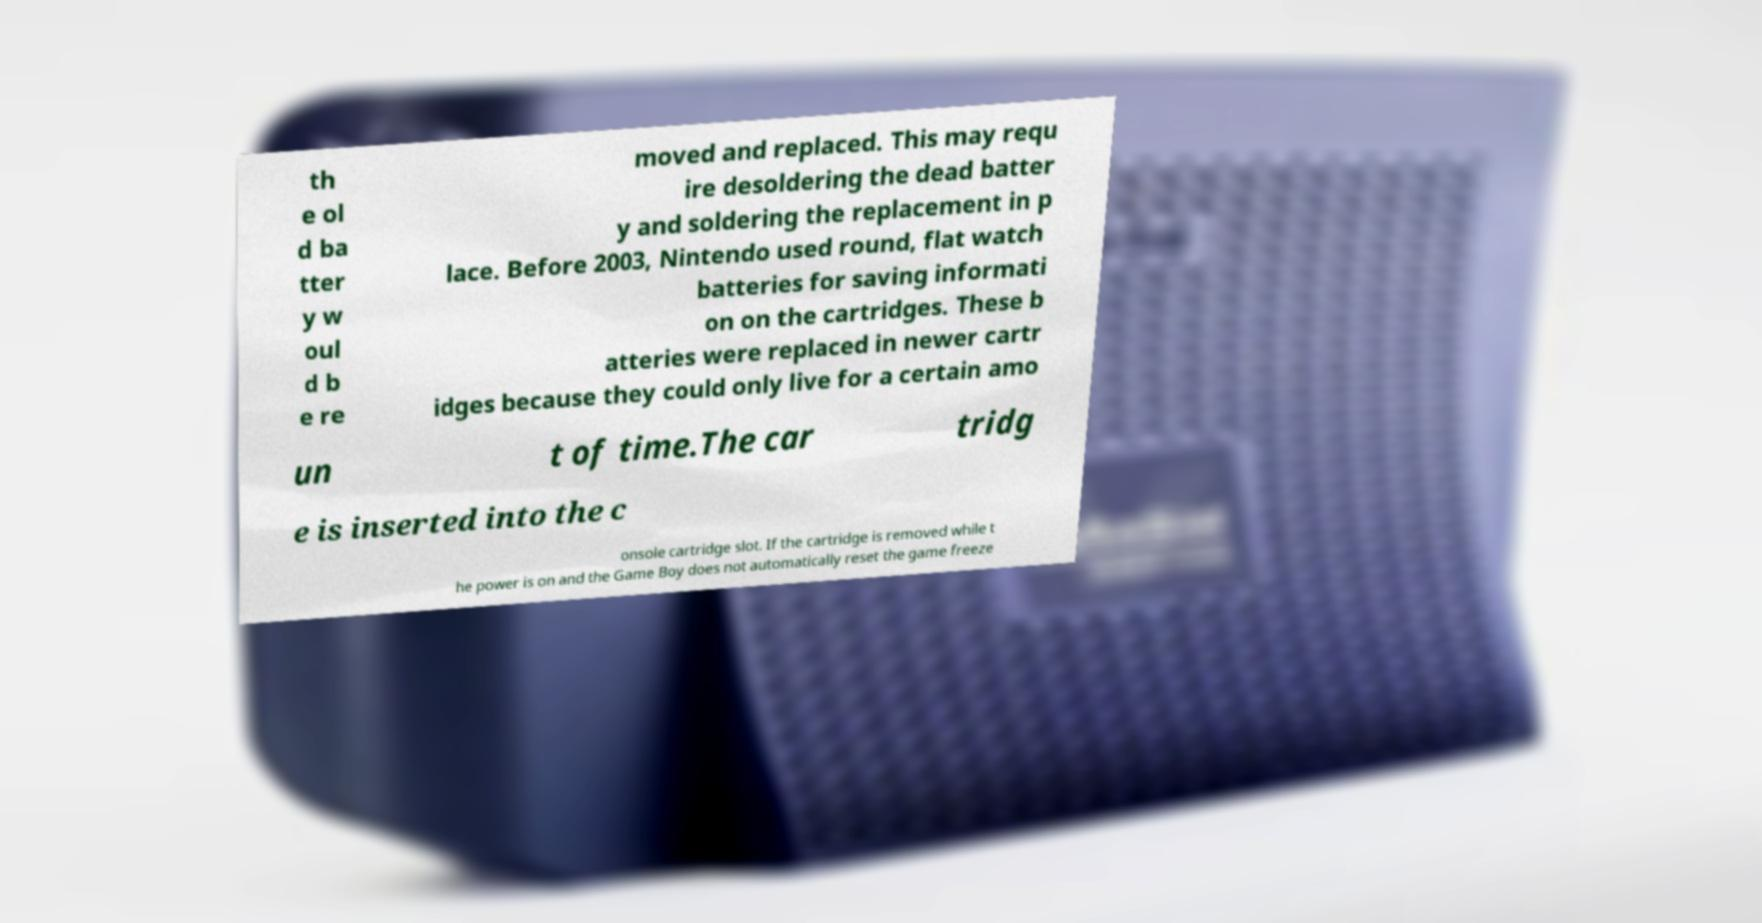For documentation purposes, I need the text within this image transcribed. Could you provide that? th e ol d ba tter y w oul d b e re moved and replaced. This may requ ire desoldering the dead batter y and soldering the replacement in p lace. Before 2003, Nintendo used round, flat watch batteries for saving informati on on the cartridges. These b atteries were replaced in newer cartr idges because they could only live for a certain amo un t of time.The car tridg e is inserted into the c onsole cartridge slot. If the cartridge is removed while t he power is on and the Game Boy does not automatically reset the game freeze 